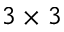Convert formula to latex. <formula><loc_0><loc_0><loc_500><loc_500>3 \times 3</formula> 